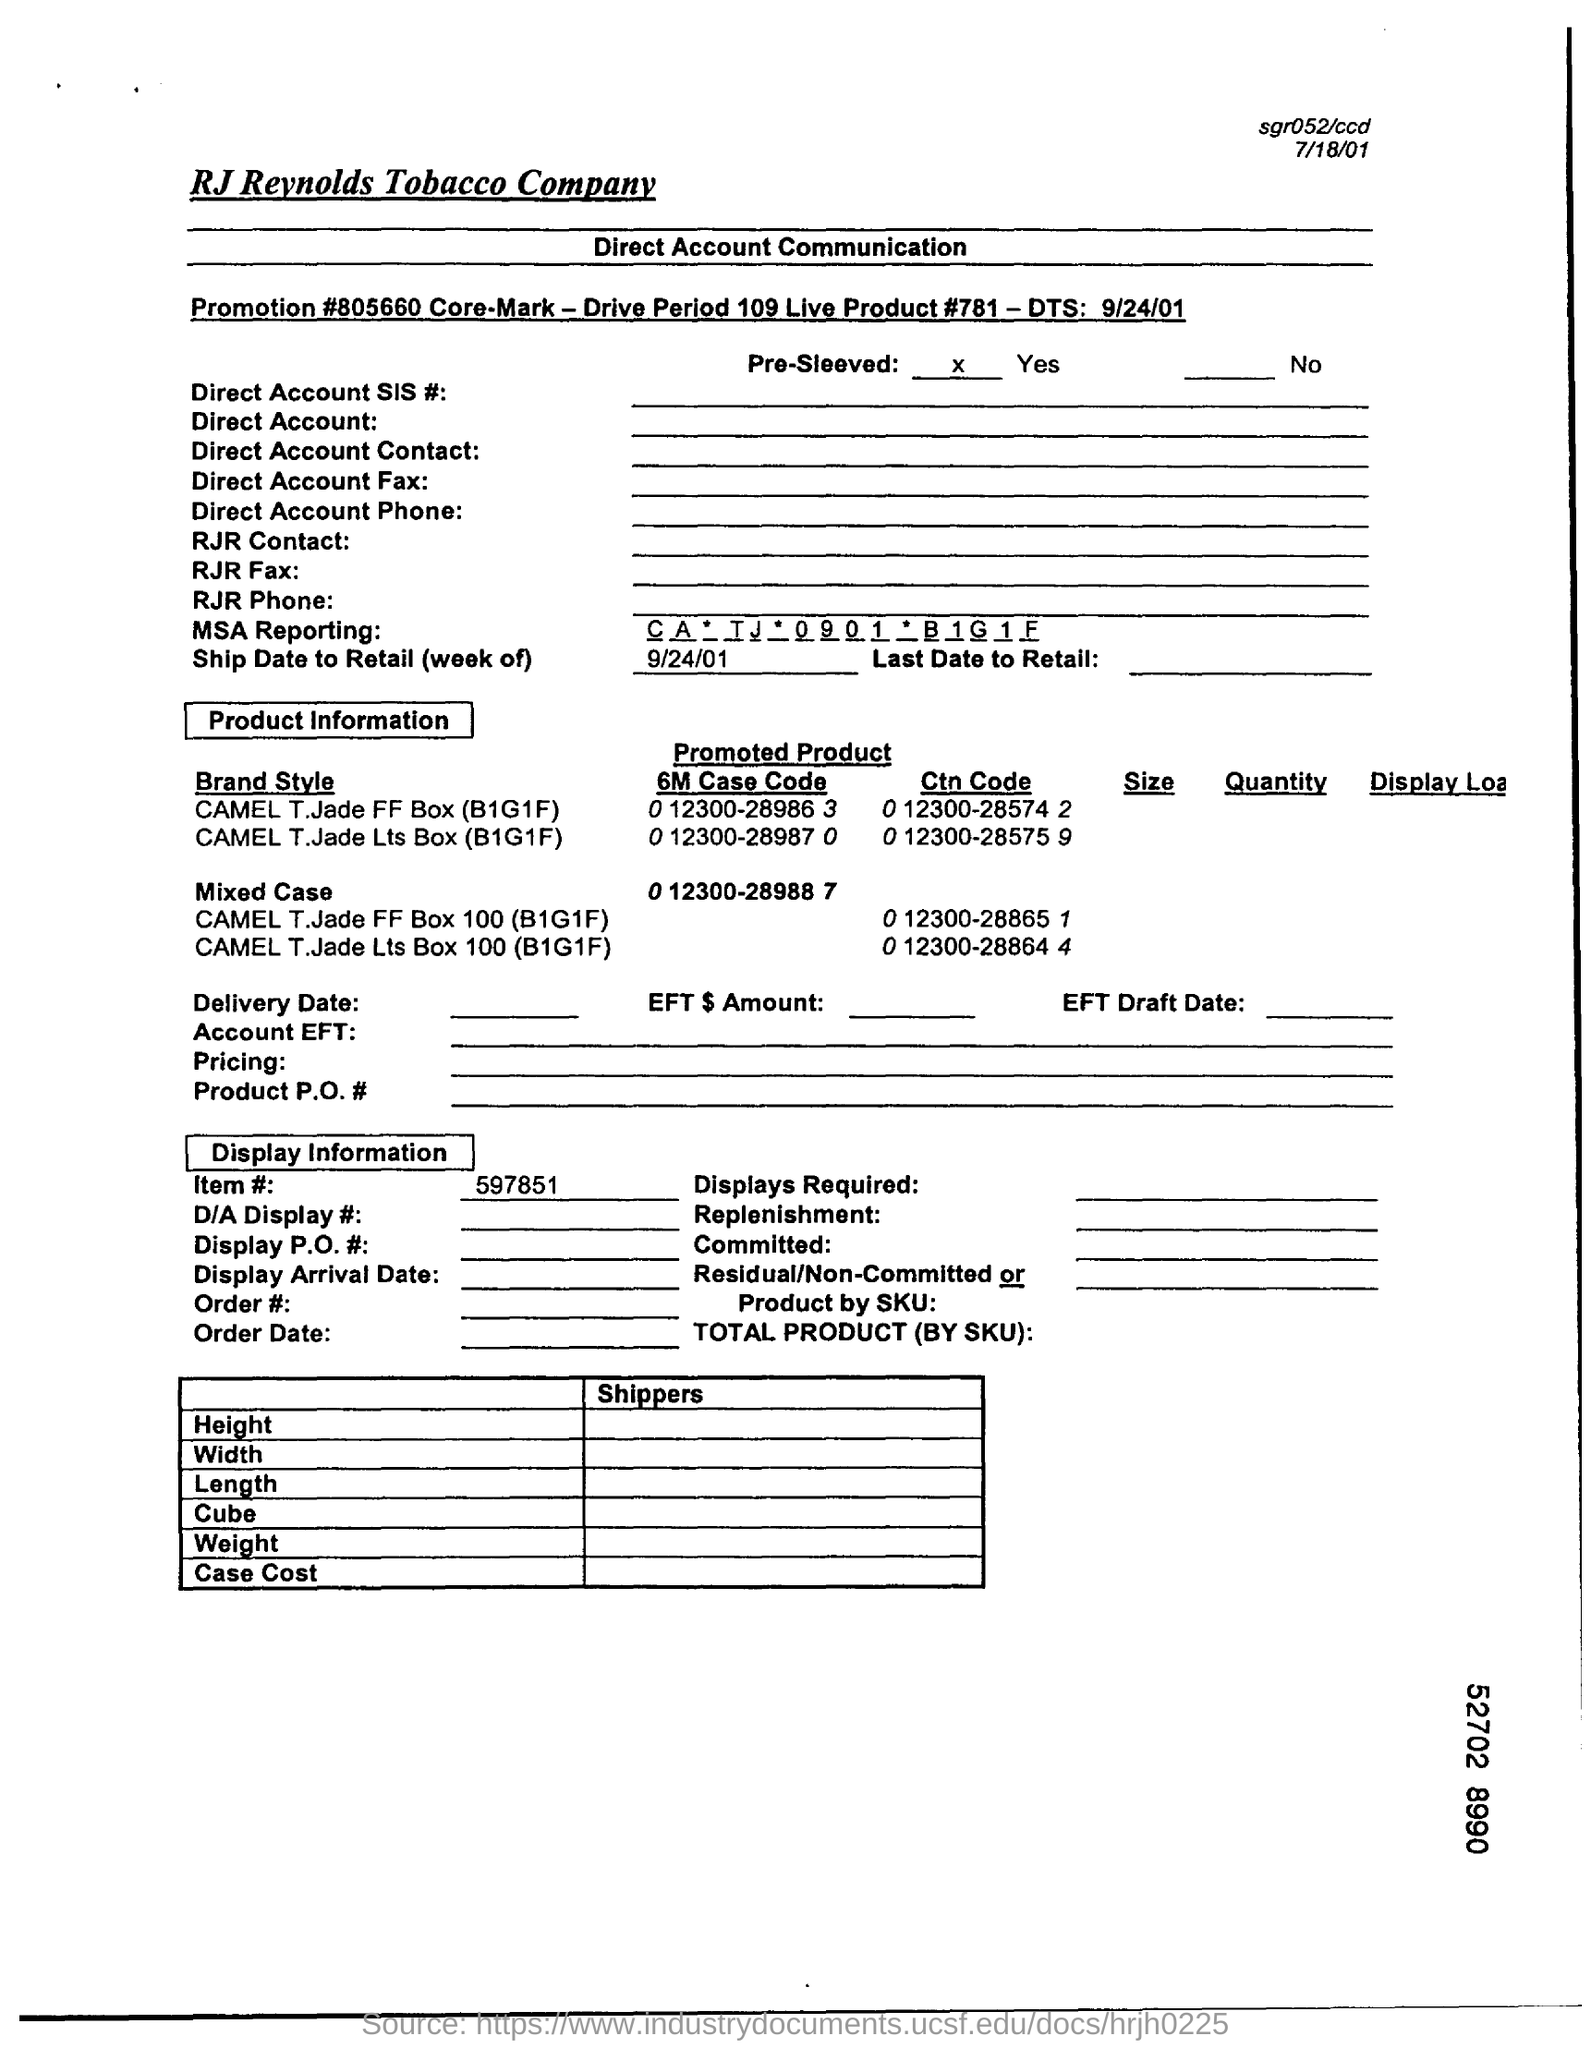Mention the company name?
Give a very brief answer. R. J. Reynolds tobacco company. What type of Communication is mentioned in this document?
Your response must be concise. Direct Account Communication. Whether the product is "Pre-Sleeved" ?
Provide a succinct answer. Yes. What is the value against title " MSA Reporting:"
Make the answer very short. Ca * TJ * 0901 * B1G1F. Which date is specified in 'Ship Date to Retail (week of)' ?
Give a very brief answer. 9/24/01. Which is the first "Brand Style" product under the title "Product Information" ?
Keep it short and to the point. CAMEL T.Jade FF Box (B1G1F). Which is the second "Mixed Case" product under the title "Product Information" ?
Your answer should be compact. CAMEL T.Jade Lts Box 100 (B1G1F). What is the 'Item #' under "Display Information" ?
Keep it short and to the point. 597851. What is the 'Promotion #' written in the first sub-heading of the document?
Provide a succinct answer. 805660. 